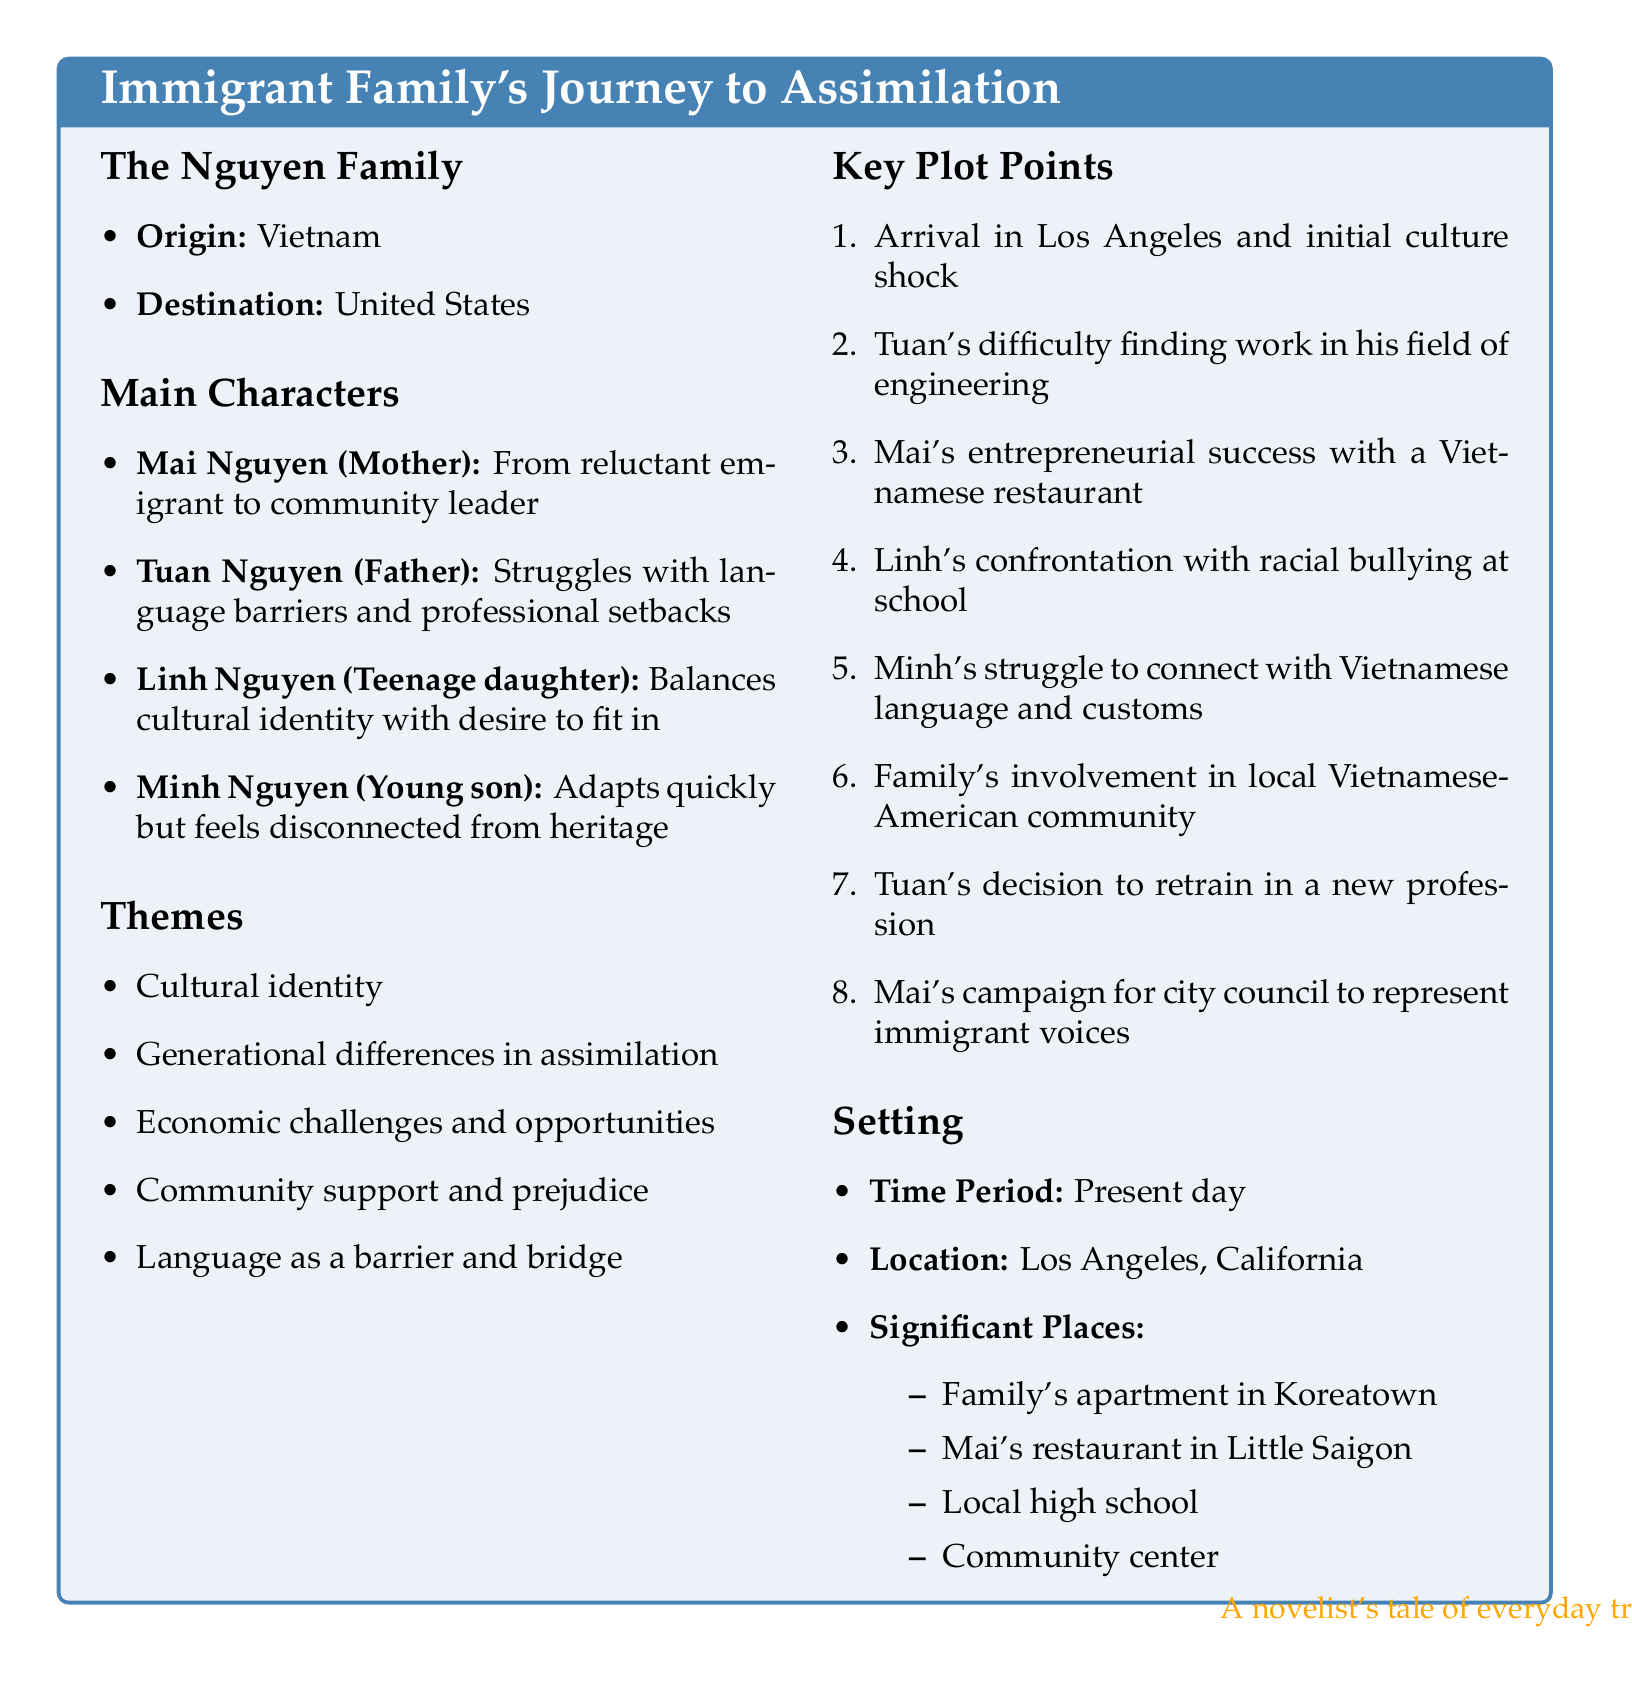What is the family name? The family name is clearly stated in the title of the document as the Nguyen Family.
Answer: Nguyen Family What is the country of origin? The document specifies that the Nguyen Family originates from Vietnam.
Answer: Vietnam Who is the teenage daughter? The document lists Linh Nguyen as the character playing the role of the teenage daughter.
Answer: Linh Nguyen What significant challenge does Tuan face? The document mentions Tuan's difficulty with language barriers and professional setbacks.
Answer: Language barriers What theme addresses cultural identity? The document outlines cultural identity as one of the central themes in the story.
Answer: Cultural identity Where is the family's apartment located? The document notes that the family's apartment is in Koreatown, Los Angeles.
Answer: Koreatown How many key plot points are outlined? The document enumerates eight key plot points in the story.
Answer: Eight What is Mai's role in the community later in the story? The document states that Mai becomes a community leader as part of her character arc.
Answer: Community leader What is the time period of the story? The document specifies that the time period of the story is present day.
Answer: Present day 